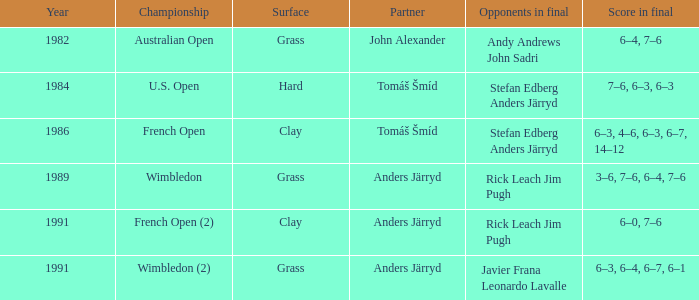Who was his teammate in 1989? Anders Järryd. 